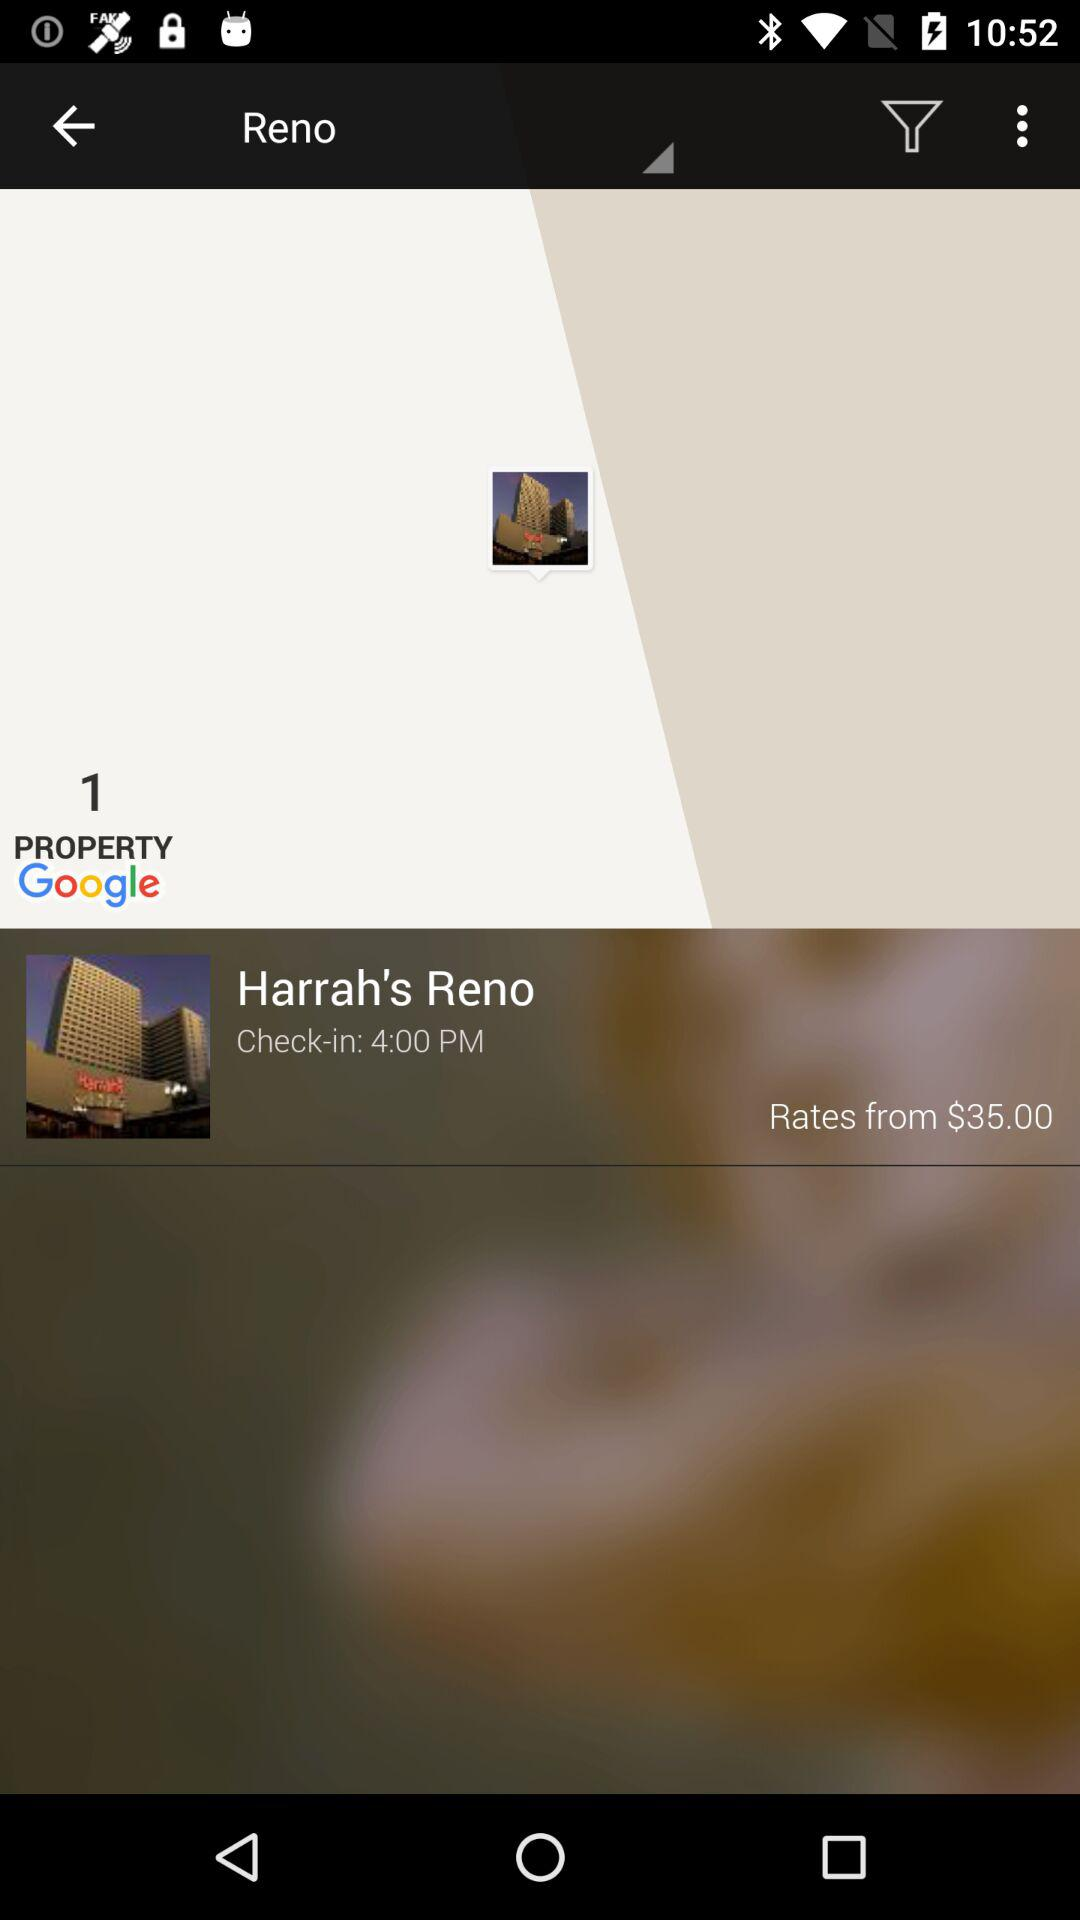What is the starting rate? The starting rate is $35. 